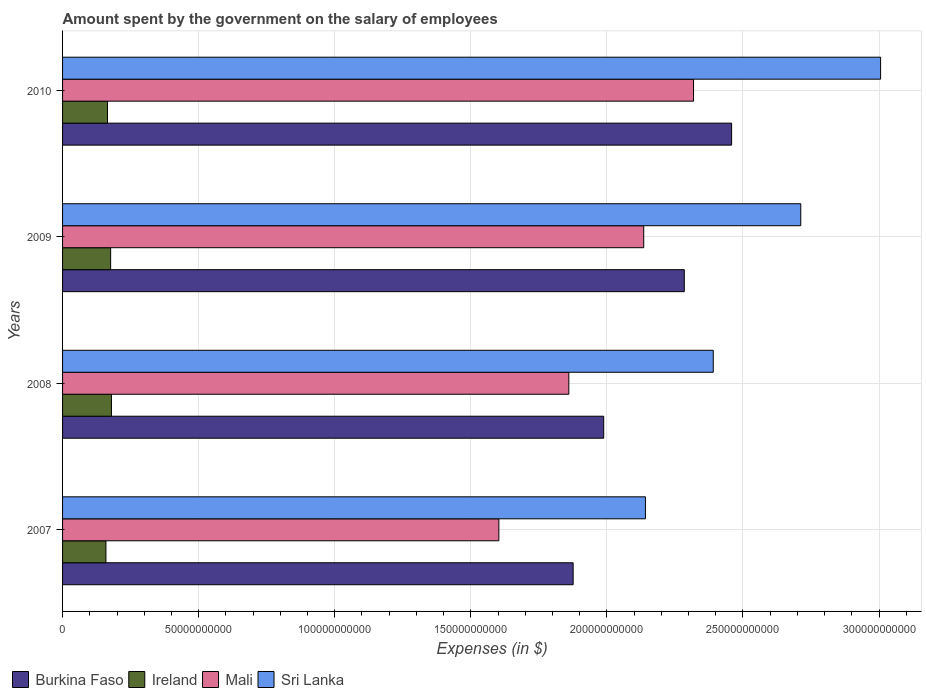Are the number of bars per tick equal to the number of legend labels?
Offer a terse response. Yes. Are the number of bars on each tick of the Y-axis equal?
Provide a short and direct response. Yes. What is the label of the 3rd group of bars from the top?
Offer a very short reply. 2008. In how many cases, is the number of bars for a given year not equal to the number of legend labels?
Make the answer very short. 0. What is the amount spent on the salary of employees by the government in Burkina Faso in 2009?
Your answer should be very brief. 2.28e+11. Across all years, what is the maximum amount spent on the salary of employees by the government in Ireland?
Ensure brevity in your answer.  1.80e+1. Across all years, what is the minimum amount spent on the salary of employees by the government in Mali?
Make the answer very short. 1.60e+11. In which year was the amount spent on the salary of employees by the government in Mali maximum?
Provide a short and direct response. 2010. In which year was the amount spent on the salary of employees by the government in Mali minimum?
Your response must be concise. 2007. What is the total amount spent on the salary of employees by the government in Mali in the graph?
Provide a succinct answer. 7.92e+11. What is the difference between the amount spent on the salary of employees by the government in Mali in 2007 and that in 2008?
Your answer should be very brief. -2.57e+1. What is the difference between the amount spent on the salary of employees by the government in Mali in 2008 and the amount spent on the salary of employees by the government in Burkina Faso in 2007?
Your answer should be very brief. -1.59e+09. What is the average amount spent on the salary of employees by the government in Sri Lanka per year?
Ensure brevity in your answer.  2.56e+11. In the year 2009, what is the difference between the amount spent on the salary of employees by the government in Mali and amount spent on the salary of employees by the government in Sri Lanka?
Keep it short and to the point. -5.77e+1. In how many years, is the amount spent on the salary of employees by the government in Mali greater than 10000000000 $?
Provide a succinct answer. 4. What is the ratio of the amount spent on the salary of employees by the government in Sri Lanka in 2007 to that in 2009?
Make the answer very short. 0.79. Is the amount spent on the salary of employees by the government in Burkina Faso in 2008 less than that in 2009?
Your answer should be compact. Yes. Is the difference between the amount spent on the salary of employees by the government in Mali in 2008 and 2010 greater than the difference between the amount spent on the salary of employees by the government in Sri Lanka in 2008 and 2010?
Offer a very short reply. Yes. What is the difference between the highest and the second highest amount spent on the salary of employees by the government in Mali?
Offer a very short reply. 1.83e+1. What is the difference between the highest and the lowest amount spent on the salary of employees by the government in Ireland?
Give a very brief answer. 2.02e+09. Is it the case that in every year, the sum of the amount spent on the salary of employees by the government in Burkina Faso and amount spent on the salary of employees by the government in Ireland is greater than the sum of amount spent on the salary of employees by the government in Mali and amount spent on the salary of employees by the government in Sri Lanka?
Keep it short and to the point. No. What does the 1st bar from the top in 2007 represents?
Your response must be concise. Sri Lanka. What does the 3rd bar from the bottom in 2008 represents?
Make the answer very short. Mali. Is it the case that in every year, the sum of the amount spent on the salary of employees by the government in Sri Lanka and amount spent on the salary of employees by the government in Ireland is greater than the amount spent on the salary of employees by the government in Mali?
Your response must be concise. Yes. Are all the bars in the graph horizontal?
Make the answer very short. Yes. How many years are there in the graph?
Keep it short and to the point. 4. How are the legend labels stacked?
Make the answer very short. Horizontal. What is the title of the graph?
Ensure brevity in your answer.  Amount spent by the government on the salary of employees. What is the label or title of the X-axis?
Ensure brevity in your answer.  Expenses (in $). What is the label or title of the Y-axis?
Provide a short and direct response. Years. What is the Expenses (in $) of Burkina Faso in 2007?
Your answer should be compact. 1.88e+11. What is the Expenses (in $) in Ireland in 2007?
Offer a very short reply. 1.59e+1. What is the Expenses (in $) in Mali in 2007?
Your answer should be compact. 1.60e+11. What is the Expenses (in $) in Sri Lanka in 2007?
Your answer should be compact. 2.14e+11. What is the Expenses (in $) in Burkina Faso in 2008?
Offer a terse response. 1.99e+11. What is the Expenses (in $) of Ireland in 2008?
Give a very brief answer. 1.80e+1. What is the Expenses (in $) of Mali in 2008?
Provide a short and direct response. 1.86e+11. What is the Expenses (in $) of Sri Lanka in 2008?
Your response must be concise. 2.39e+11. What is the Expenses (in $) in Burkina Faso in 2009?
Ensure brevity in your answer.  2.28e+11. What is the Expenses (in $) of Ireland in 2009?
Offer a terse response. 1.77e+1. What is the Expenses (in $) in Mali in 2009?
Make the answer very short. 2.14e+11. What is the Expenses (in $) in Sri Lanka in 2009?
Provide a succinct answer. 2.71e+11. What is the Expenses (in $) of Burkina Faso in 2010?
Make the answer very short. 2.46e+11. What is the Expenses (in $) in Ireland in 2010?
Keep it short and to the point. 1.65e+1. What is the Expenses (in $) in Mali in 2010?
Make the answer very short. 2.32e+11. What is the Expenses (in $) of Sri Lanka in 2010?
Make the answer very short. 3.01e+11. Across all years, what is the maximum Expenses (in $) of Burkina Faso?
Provide a succinct answer. 2.46e+11. Across all years, what is the maximum Expenses (in $) in Ireland?
Provide a short and direct response. 1.80e+1. Across all years, what is the maximum Expenses (in $) in Mali?
Your response must be concise. 2.32e+11. Across all years, what is the maximum Expenses (in $) in Sri Lanka?
Provide a succinct answer. 3.01e+11. Across all years, what is the minimum Expenses (in $) of Burkina Faso?
Provide a short and direct response. 1.88e+11. Across all years, what is the minimum Expenses (in $) of Ireland?
Make the answer very short. 1.59e+1. Across all years, what is the minimum Expenses (in $) in Mali?
Your answer should be compact. 1.60e+11. Across all years, what is the minimum Expenses (in $) in Sri Lanka?
Make the answer very short. 2.14e+11. What is the total Expenses (in $) of Burkina Faso in the graph?
Make the answer very short. 8.61e+11. What is the total Expenses (in $) in Ireland in the graph?
Provide a succinct answer. 6.81e+1. What is the total Expenses (in $) of Mali in the graph?
Make the answer very short. 7.92e+11. What is the total Expenses (in $) in Sri Lanka in the graph?
Your response must be concise. 1.03e+12. What is the difference between the Expenses (in $) in Burkina Faso in 2007 and that in 2008?
Give a very brief answer. -1.12e+1. What is the difference between the Expenses (in $) in Ireland in 2007 and that in 2008?
Your answer should be compact. -2.02e+09. What is the difference between the Expenses (in $) of Mali in 2007 and that in 2008?
Give a very brief answer. -2.57e+1. What is the difference between the Expenses (in $) in Sri Lanka in 2007 and that in 2008?
Make the answer very short. -2.49e+1. What is the difference between the Expenses (in $) of Burkina Faso in 2007 and that in 2009?
Your answer should be very brief. -4.08e+1. What is the difference between the Expenses (in $) in Ireland in 2007 and that in 2009?
Make the answer very short. -1.73e+09. What is the difference between the Expenses (in $) in Mali in 2007 and that in 2009?
Your answer should be very brief. -5.32e+1. What is the difference between the Expenses (in $) in Sri Lanka in 2007 and that in 2009?
Keep it short and to the point. -5.71e+1. What is the difference between the Expenses (in $) of Burkina Faso in 2007 and that in 2010?
Provide a short and direct response. -5.82e+1. What is the difference between the Expenses (in $) of Ireland in 2007 and that in 2010?
Your answer should be very brief. -5.68e+08. What is the difference between the Expenses (in $) in Mali in 2007 and that in 2010?
Make the answer very short. -7.15e+1. What is the difference between the Expenses (in $) of Sri Lanka in 2007 and that in 2010?
Ensure brevity in your answer.  -8.64e+1. What is the difference between the Expenses (in $) of Burkina Faso in 2008 and that in 2009?
Give a very brief answer. -2.96e+1. What is the difference between the Expenses (in $) in Ireland in 2008 and that in 2009?
Offer a very short reply. 2.99e+08. What is the difference between the Expenses (in $) in Mali in 2008 and that in 2009?
Give a very brief answer. -2.75e+1. What is the difference between the Expenses (in $) of Sri Lanka in 2008 and that in 2009?
Ensure brevity in your answer.  -3.22e+1. What is the difference between the Expenses (in $) of Burkina Faso in 2008 and that in 2010?
Your answer should be compact. -4.70e+1. What is the difference between the Expenses (in $) of Ireland in 2008 and that in 2010?
Offer a very short reply. 1.46e+09. What is the difference between the Expenses (in $) of Mali in 2008 and that in 2010?
Your response must be concise. -4.58e+1. What is the difference between the Expenses (in $) in Sri Lanka in 2008 and that in 2010?
Give a very brief answer. -6.15e+1. What is the difference between the Expenses (in $) in Burkina Faso in 2009 and that in 2010?
Your answer should be compact. -1.74e+1. What is the difference between the Expenses (in $) of Ireland in 2009 and that in 2010?
Provide a succinct answer. 1.16e+09. What is the difference between the Expenses (in $) of Mali in 2009 and that in 2010?
Offer a terse response. -1.83e+1. What is the difference between the Expenses (in $) in Sri Lanka in 2009 and that in 2010?
Make the answer very short. -2.93e+1. What is the difference between the Expenses (in $) in Burkina Faso in 2007 and the Expenses (in $) in Ireland in 2008?
Your answer should be very brief. 1.70e+11. What is the difference between the Expenses (in $) of Burkina Faso in 2007 and the Expenses (in $) of Mali in 2008?
Keep it short and to the point. 1.59e+09. What is the difference between the Expenses (in $) of Burkina Faso in 2007 and the Expenses (in $) of Sri Lanka in 2008?
Make the answer very short. -5.15e+1. What is the difference between the Expenses (in $) of Ireland in 2007 and the Expenses (in $) of Mali in 2008?
Offer a very short reply. -1.70e+11. What is the difference between the Expenses (in $) of Ireland in 2007 and the Expenses (in $) of Sri Lanka in 2008?
Provide a succinct answer. -2.23e+11. What is the difference between the Expenses (in $) of Mali in 2007 and the Expenses (in $) of Sri Lanka in 2008?
Give a very brief answer. -7.88e+1. What is the difference between the Expenses (in $) of Burkina Faso in 2007 and the Expenses (in $) of Ireland in 2009?
Provide a short and direct response. 1.70e+11. What is the difference between the Expenses (in $) in Burkina Faso in 2007 and the Expenses (in $) in Mali in 2009?
Keep it short and to the point. -2.59e+1. What is the difference between the Expenses (in $) of Burkina Faso in 2007 and the Expenses (in $) of Sri Lanka in 2009?
Your answer should be compact. -8.36e+1. What is the difference between the Expenses (in $) in Ireland in 2007 and the Expenses (in $) in Mali in 2009?
Your answer should be very brief. -1.98e+11. What is the difference between the Expenses (in $) of Ireland in 2007 and the Expenses (in $) of Sri Lanka in 2009?
Offer a terse response. -2.55e+11. What is the difference between the Expenses (in $) of Mali in 2007 and the Expenses (in $) of Sri Lanka in 2009?
Provide a short and direct response. -1.11e+11. What is the difference between the Expenses (in $) in Burkina Faso in 2007 and the Expenses (in $) in Ireland in 2010?
Your response must be concise. 1.71e+11. What is the difference between the Expenses (in $) of Burkina Faso in 2007 and the Expenses (in $) of Mali in 2010?
Keep it short and to the point. -4.42e+1. What is the difference between the Expenses (in $) of Burkina Faso in 2007 and the Expenses (in $) of Sri Lanka in 2010?
Offer a very short reply. -1.13e+11. What is the difference between the Expenses (in $) of Ireland in 2007 and the Expenses (in $) of Mali in 2010?
Provide a short and direct response. -2.16e+11. What is the difference between the Expenses (in $) in Ireland in 2007 and the Expenses (in $) in Sri Lanka in 2010?
Your answer should be very brief. -2.85e+11. What is the difference between the Expenses (in $) of Mali in 2007 and the Expenses (in $) of Sri Lanka in 2010?
Keep it short and to the point. -1.40e+11. What is the difference between the Expenses (in $) of Burkina Faso in 2008 and the Expenses (in $) of Ireland in 2009?
Your response must be concise. 1.81e+11. What is the difference between the Expenses (in $) of Burkina Faso in 2008 and the Expenses (in $) of Mali in 2009?
Ensure brevity in your answer.  -1.47e+1. What is the difference between the Expenses (in $) of Burkina Faso in 2008 and the Expenses (in $) of Sri Lanka in 2009?
Give a very brief answer. -7.24e+1. What is the difference between the Expenses (in $) of Ireland in 2008 and the Expenses (in $) of Mali in 2009?
Offer a terse response. -1.96e+11. What is the difference between the Expenses (in $) of Ireland in 2008 and the Expenses (in $) of Sri Lanka in 2009?
Ensure brevity in your answer.  -2.53e+11. What is the difference between the Expenses (in $) in Mali in 2008 and the Expenses (in $) in Sri Lanka in 2009?
Keep it short and to the point. -8.52e+1. What is the difference between the Expenses (in $) in Burkina Faso in 2008 and the Expenses (in $) in Ireland in 2010?
Give a very brief answer. 1.82e+11. What is the difference between the Expenses (in $) of Burkina Faso in 2008 and the Expenses (in $) of Mali in 2010?
Offer a terse response. -3.30e+1. What is the difference between the Expenses (in $) in Burkina Faso in 2008 and the Expenses (in $) in Sri Lanka in 2010?
Offer a terse response. -1.02e+11. What is the difference between the Expenses (in $) in Ireland in 2008 and the Expenses (in $) in Mali in 2010?
Your answer should be compact. -2.14e+11. What is the difference between the Expenses (in $) of Ireland in 2008 and the Expenses (in $) of Sri Lanka in 2010?
Ensure brevity in your answer.  -2.83e+11. What is the difference between the Expenses (in $) of Mali in 2008 and the Expenses (in $) of Sri Lanka in 2010?
Keep it short and to the point. -1.15e+11. What is the difference between the Expenses (in $) of Burkina Faso in 2009 and the Expenses (in $) of Ireland in 2010?
Ensure brevity in your answer.  2.12e+11. What is the difference between the Expenses (in $) of Burkina Faso in 2009 and the Expenses (in $) of Mali in 2010?
Keep it short and to the point. -3.40e+09. What is the difference between the Expenses (in $) of Burkina Faso in 2009 and the Expenses (in $) of Sri Lanka in 2010?
Your response must be concise. -7.21e+1. What is the difference between the Expenses (in $) in Ireland in 2009 and the Expenses (in $) in Mali in 2010?
Provide a succinct answer. -2.14e+11. What is the difference between the Expenses (in $) of Ireland in 2009 and the Expenses (in $) of Sri Lanka in 2010?
Keep it short and to the point. -2.83e+11. What is the difference between the Expenses (in $) of Mali in 2009 and the Expenses (in $) of Sri Lanka in 2010?
Provide a short and direct response. -8.70e+1. What is the average Expenses (in $) in Burkina Faso per year?
Offer a terse response. 2.15e+11. What is the average Expenses (in $) in Ireland per year?
Your response must be concise. 1.70e+1. What is the average Expenses (in $) in Mali per year?
Ensure brevity in your answer.  1.98e+11. What is the average Expenses (in $) of Sri Lanka per year?
Your answer should be very brief. 2.56e+11. In the year 2007, what is the difference between the Expenses (in $) of Burkina Faso and Expenses (in $) of Ireland?
Offer a terse response. 1.72e+11. In the year 2007, what is the difference between the Expenses (in $) of Burkina Faso and Expenses (in $) of Mali?
Keep it short and to the point. 2.73e+1. In the year 2007, what is the difference between the Expenses (in $) in Burkina Faso and Expenses (in $) in Sri Lanka?
Ensure brevity in your answer.  -2.66e+1. In the year 2007, what is the difference between the Expenses (in $) in Ireland and Expenses (in $) in Mali?
Make the answer very short. -1.44e+11. In the year 2007, what is the difference between the Expenses (in $) of Ireland and Expenses (in $) of Sri Lanka?
Provide a short and direct response. -1.98e+11. In the year 2007, what is the difference between the Expenses (in $) of Mali and Expenses (in $) of Sri Lanka?
Ensure brevity in your answer.  -5.39e+1. In the year 2008, what is the difference between the Expenses (in $) in Burkina Faso and Expenses (in $) in Ireland?
Your answer should be very brief. 1.81e+11. In the year 2008, what is the difference between the Expenses (in $) in Burkina Faso and Expenses (in $) in Mali?
Offer a terse response. 1.28e+1. In the year 2008, what is the difference between the Expenses (in $) in Burkina Faso and Expenses (in $) in Sri Lanka?
Offer a very short reply. -4.03e+1. In the year 2008, what is the difference between the Expenses (in $) of Ireland and Expenses (in $) of Mali?
Make the answer very short. -1.68e+11. In the year 2008, what is the difference between the Expenses (in $) of Ireland and Expenses (in $) of Sri Lanka?
Ensure brevity in your answer.  -2.21e+11. In the year 2008, what is the difference between the Expenses (in $) in Mali and Expenses (in $) in Sri Lanka?
Provide a short and direct response. -5.31e+1. In the year 2009, what is the difference between the Expenses (in $) in Burkina Faso and Expenses (in $) in Ireland?
Provide a short and direct response. 2.11e+11. In the year 2009, what is the difference between the Expenses (in $) of Burkina Faso and Expenses (in $) of Mali?
Your answer should be compact. 1.49e+1. In the year 2009, what is the difference between the Expenses (in $) in Burkina Faso and Expenses (in $) in Sri Lanka?
Provide a succinct answer. -4.28e+1. In the year 2009, what is the difference between the Expenses (in $) of Ireland and Expenses (in $) of Mali?
Your answer should be compact. -1.96e+11. In the year 2009, what is the difference between the Expenses (in $) of Ireland and Expenses (in $) of Sri Lanka?
Provide a short and direct response. -2.54e+11. In the year 2009, what is the difference between the Expenses (in $) of Mali and Expenses (in $) of Sri Lanka?
Your answer should be compact. -5.77e+1. In the year 2010, what is the difference between the Expenses (in $) in Burkina Faso and Expenses (in $) in Ireland?
Offer a very short reply. 2.29e+11. In the year 2010, what is the difference between the Expenses (in $) in Burkina Faso and Expenses (in $) in Mali?
Give a very brief answer. 1.40e+1. In the year 2010, what is the difference between the Expenses (in $) of Burkina Faso and Expenses (in $) of Sri Lanka?
Make the answer very short. -5.47e+1. In the year 2010, what is the difference between the Expenses (in $) in Ireland and Expenses (in $) in Mali?
Your answer should be compact. -2.15e+11. In the year 2010, what is the difference between the Expenses (in $) in Ireland and Expenses (in $) in Sri Lanka?
Your answer should be compact. -2.84e+11. In the year 2010, what is the difference between the Expenses (in $) of Mali and Expenses (in $) of Sri Lanka?
Offer a terse response. -6.87e+1. What is the ratio of the Expenses (in $) of Burkina Faso in 2007 to that in 2008?
Ensure brevity in your answer.  0.94. What is the ratio of the Expenses (in $) of Ireland in 2007 to that in 2008?
Provide a short and direct response. 0.89. What is the ratio of the Expenses (in $) in Mali in 2007 to that in 2008?
Offer a very short reply. 0.86. What is the ratio of the Expenses (in $) of Sri Lanka in 2007 to that in 2008?
Provide a succinct answer. 0.9. What is the ratio of the Expenses (in $) in Burkina Faso in 2007 to that in 2009?
Offer a terse response. 0.82. What is the ratio of the Expenses (in $) in Ireland in 2007 to that in 2009?
Offer a very short reply. 0.9. What is the ratio of the Expenses (in $) of Mali in 2007 to that in 2009?
Keep it short and to the point. 0.75. What is the ratio of the Expenses (in $) in Sri Lanka in 2007 to that in 2009?
Provide a succinct answer. 0.79. What is the ratio of the Expenses (in $) of Burkina Faso in 2007 to that in 2010?
Your answer should be compact. 0.76. What is the ratio of the Expenses (in $) of Ireland in 2007 to that in 2010?
Keep it short and to the point. 0.97. What is the ratio of the Expenses (in $) in Mali in 2007 to that in 2010?
Ensure brevity in your answer.  0.69. What is the ratio of the Expenses (in $) in Sri Lanka in 2007 to that in 2010?
Your answer should be very brief. 0.71. What is the ratio of the Expenses (in $) in Burkina Faso in 2008 to that in 2009?
Keep it short and to the point. 0.87. What is the ratio of the Expenses (in $) in Ireland in 2008 to that in 2009?
Provide a short and direct response. 1.02. What is the ratio of the Expenses (in $) of Mali in 2008 to that in 2009?
Offer a very short reply. 0.87. What is the ratio of the Expenses (in $) in Sri Lanka in 2008 to that in 2009?
Provide a short and direct response. 0.88. What is the ratio of the Expenses (in $) in Burkina Faso in 2008 to that in 2010?
Ensure brevity in your answer.  0.81. What is the ratio of the Expenses (in $) in Ireland in 2008 to that in 2010?
Your response must be concise. 1.09. What is the ratio of the Expenses (in $) of Mali in 2008 to that in 2010?
Make the answer very short. 0.8. What is the ratio of the Expenses (in $) in Sri Lanka in 2008 to that in 2010?
Give a very brief answer. 0.8. What is the ratio of the Expenses (in $) in Burkina Faso in 2009 to that in 2010?
Make the answer very short. 0.93. What is the ratio of the Expenses (in $) in Ireland in 2009 to that in 2010?
Provide a short and direct response. 1.07. What is the ratio of the Expenses (in $) of Mali in 2009 to that in 2010?
Your response must be concise. 0.92. What is the ratio of the Expenses (in $) of Sri Lanka in 2009 to that in 2010?
Your response must be concise. 0.9. What is the difference between the highest and the second highest Expenses (in $) of Burkina Faso?
Ensure brevity in your answer.  1.74e+1. What is the difference between the highest and the second highest Expenses (in $) of Ireland?
Ensure brevity in your answer.  2.99e+08. What is the difference between the highest and the second highest Expenses (in $) of Mali?
Ensure brevity in your answer.  1.83e+1. What is the difference between the highest and the second highest Expenses (in $) of Sri Lanka?
Your response must be concise. 2.93e+1. What is the difference between the highest and the lowest Expenses (in $) in Burkina Faso?
Your response must be concise. 5.82e+1. What is the difference between the highest and the lowest Expenses (in $) in Ireland?
Make the answer very short. 2.02e+09. What is the difference between the highest and the lowest Expenses (in $) in Mali?
Your response must be concise. 7.15e+1. What is the difference between the highest and the lowest Expenses (in $) of Sri Lanka?
Keep it short and to the point. 8.64e+1. 